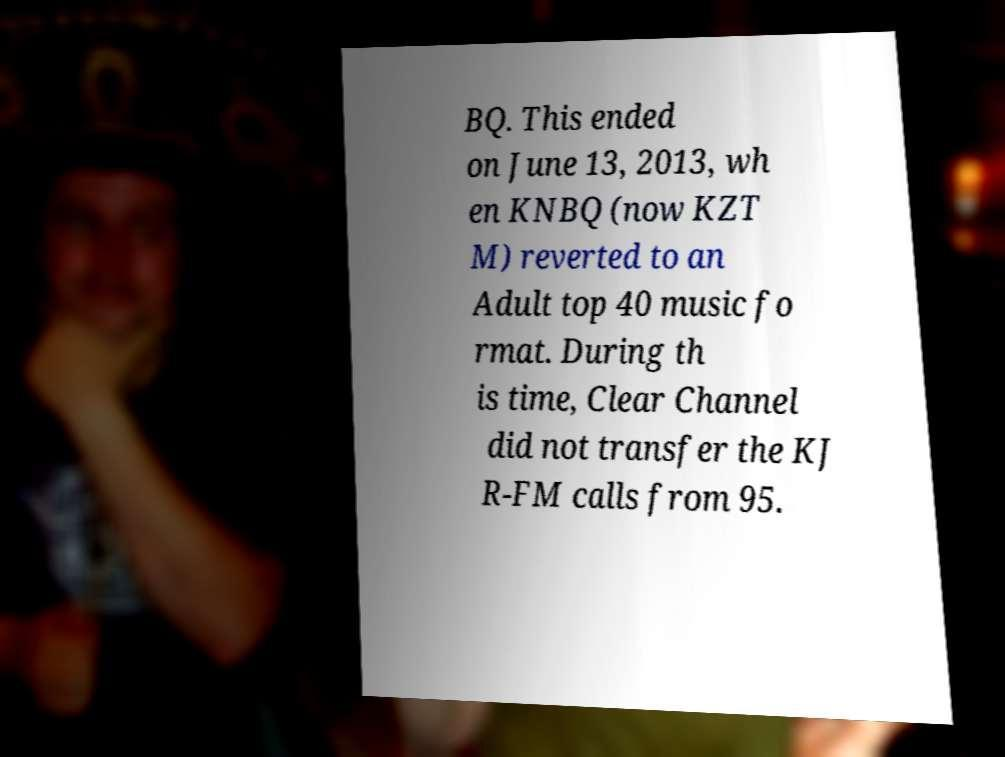There's text embedded in this image that I need extracted. Can you transcribe it verbatim? BQ. This ended on June 13, 2013, wh en KNBQ (now KZT M) reverted to an Adult top 40 music fo rmat. During th is time, Clear Channel did not transfer the KJ R-FM calls from 95. 